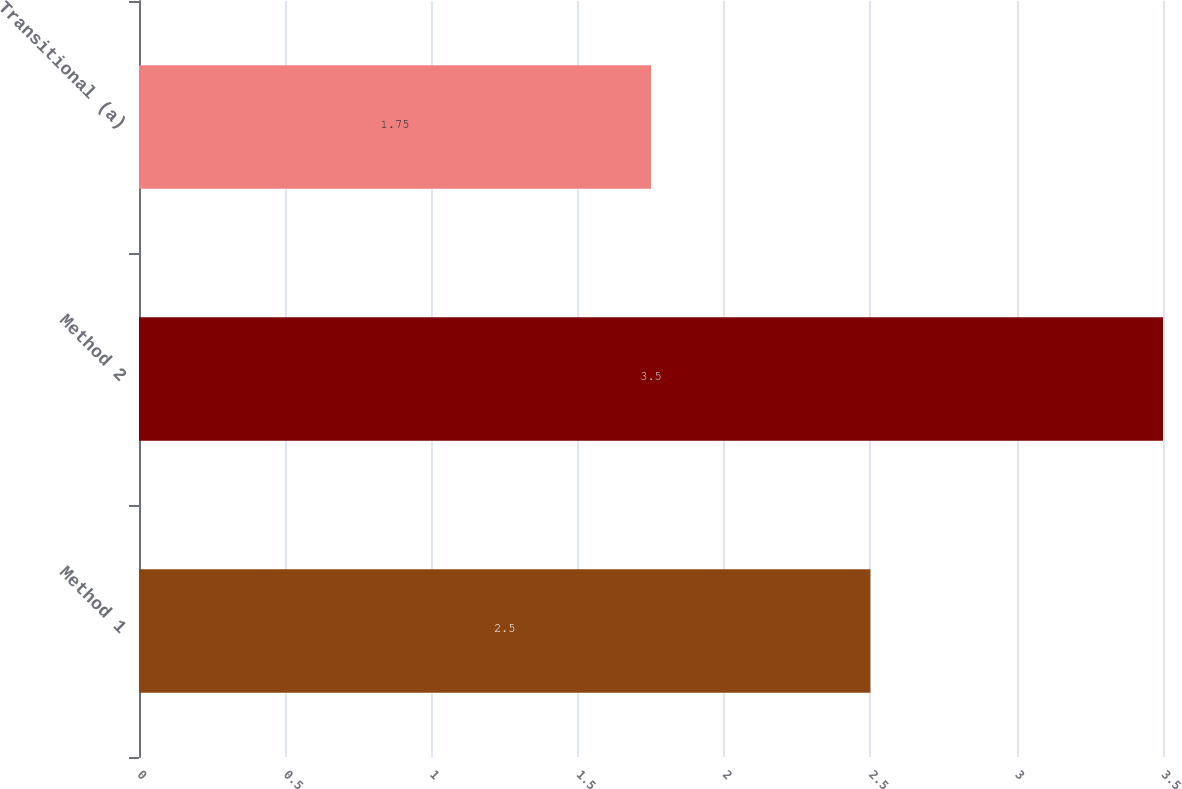<chart> <loc_0><loc_0><loc_500><loc_500><bar_chart><fcel>Method 1<fcel>Method 2<fcel>Transitional (a)<nl><fcel>2.5<fcel>3.5<fcel>1.75<nl></chart> 